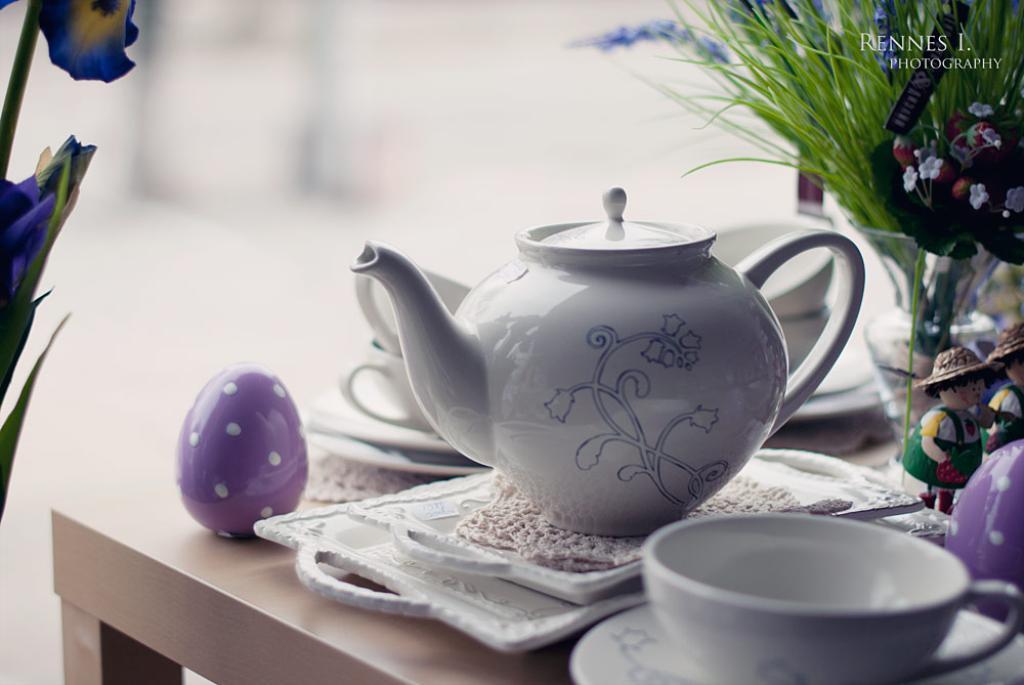Describe this image in one or two sentences. In this image we can see a teapot, tea cups and many objects on the table. There is a flower to the plant. There are some toys in the image. There is a vase and plants in the image. 